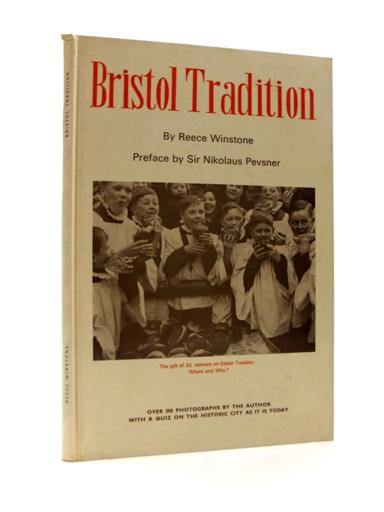What might be the historical significance of the church shown in the photograph? The church depicted in the photograph is likely an important cultural and religious landmark in Bristol, serving as a gathering place for the community. Its historical significance might stem from its architectural style, age, or the events it has witnessed, playing a crucial role in the spiritual and social fabric of the area. Can you tell more about the architectural style visible? The architecture of the church, as partially visible, seems to exhibit elements typical of Gothic Revival style, characterized by pointed arches, intricate tracery, and tall windows. Such style suggests a re-interpretation of medieval Gothic architecture, popular in historical buildings across many parts of England. 